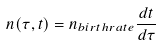<formula> <loc_0><loc_0><loc_500><loc_500>n ( \tau , t ) = n _ { b i r t h r a t e } \frac { d t } { d \tau }</formula> 